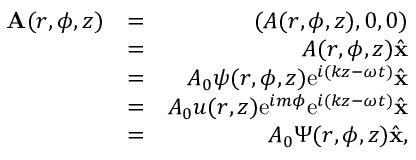<formula> <loc_0><loc_0><loc_500><loc_500>\begin{array} { r l r } { { A } ( r , \phi , z ) } & { = } & { ( A ( r , \phi , z ) , 0 , 0 ) } \\ & { = } & { A ( r , \phi , z ) \hat { x } } \\ & { = } & { A _ { 0 } \psi ( r , \phi , z ) e ^ { i ( k z - \omega t ) } \hat { x } } \\ & { = } & { A _ { 0 } u ( r , z ) e ^ { i m \phi } e ^ { i ( k z - \omega t ) } \hat { x } } \\ & { = } & { A _ { 0 } \Psi ( r , \phi , z ) \hat { x } , } \end{array}</formula> 